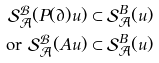<formula> <loc_0><loc_0><loc_500><loc_500>\mathcal { S } _ { \mathcal { A } } ^ { \mathcal { B } } ( P ( \partial ) u ) & \subset \mathcal { S } _ { \mathcal { A } } ^ { B } ( u ) \\ \text {or } \mathcal { S } _ { \mathcal { A } } ^ { \mathcal { B } } ( A u ) & \subset \mathcal { S } _ { \mathcal { A } } ^ { B } ( u )</formula> 